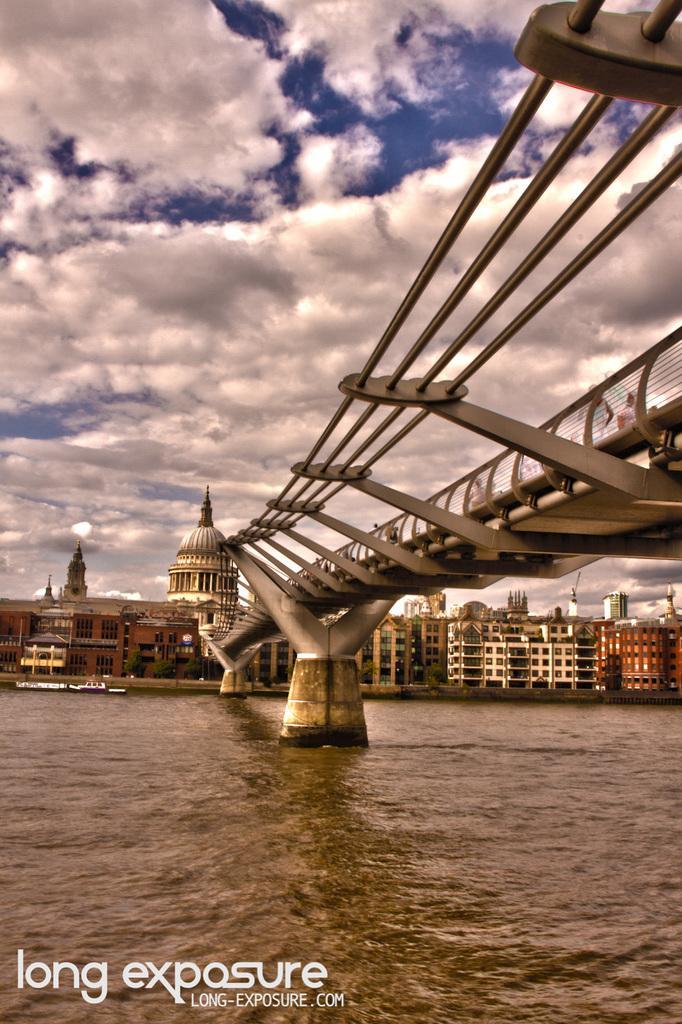Could you give a brief overview of what you see in this image? Here in this picture we can see a bridge, that is present in between the river, as we can see pillars in the water over there and in the far we can see buildings present all over there and we can see the sky is full of clouds over there. 